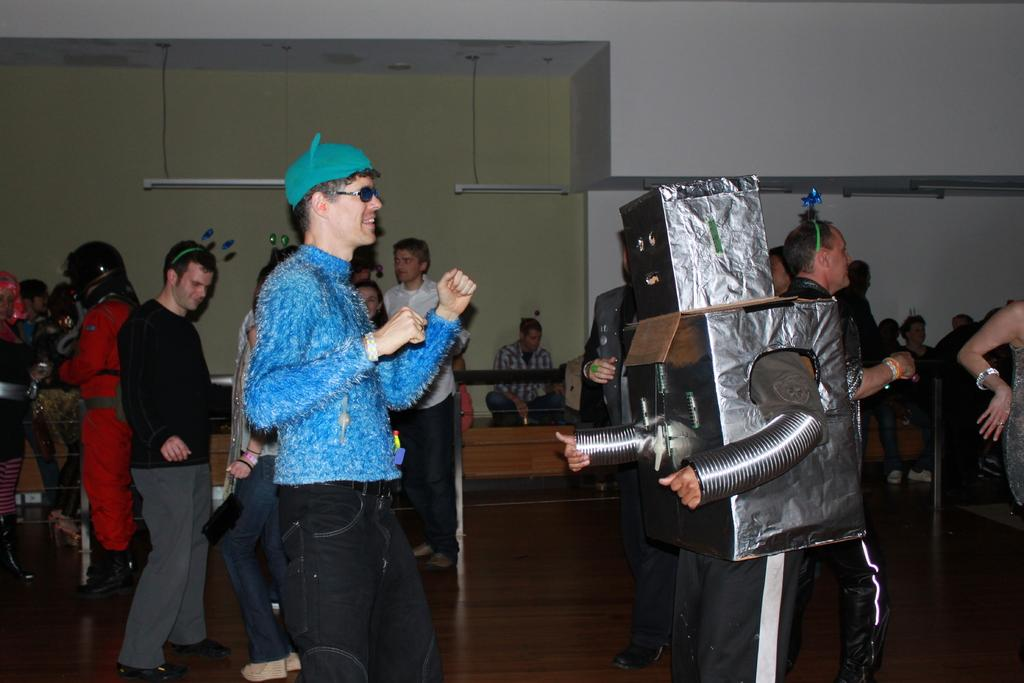What are the people in the image doing? The people in the image are dancing. Can you describe the costume of one of the dancers? One person is wearing a robot costume. What can be seen hanging from the roof in the image? There are lights hanging from the roof in the image. What is the price of the boat in the image? There is no boat present in the image, so it is not possible to determine its price. 